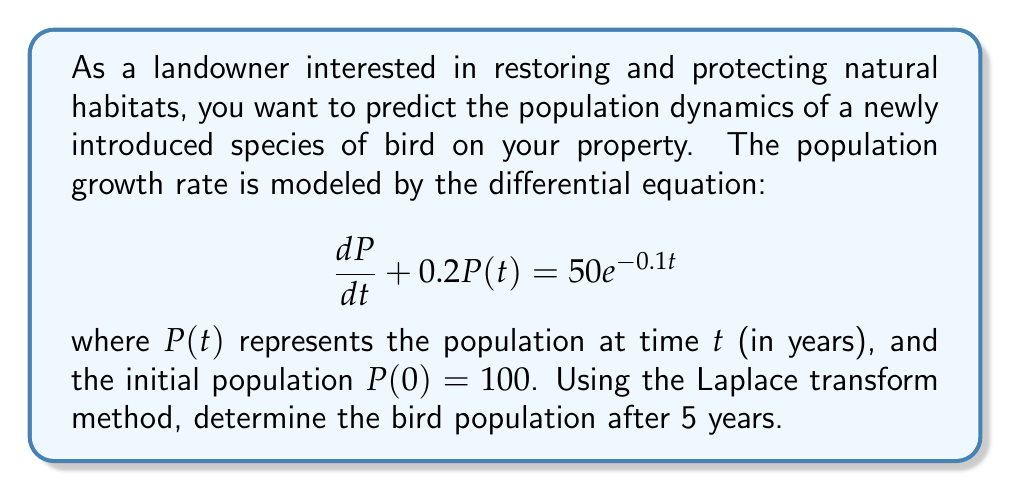Help me with this question. Let's solve this problem step-by-step using the Laplace transform method:

1) Take the Laplace transform of both sides of the equation:
   $$\mathcal{L}\{\frac{dP}{dt} + 0.2P(t)\} = \mathcal{L}\{50e^{-0.1t}\}$$

2) Using Laplace transform properties:
   $$sP(s) - P(0) + 0.2P(s) = \frac{50}{s+0.1}$$

3) Substitute the initial condition $P(0) = 100$:
   $$sP(s) - 100 + 0.2P(s) = \frac{50}{s+0.1}$$

4) Simplify:
   $$(s + 0.2)P(s) = 100 + \frac{50}{s+0.1}$$

5) Solve for $P(s)$:
   $$P(s) = \frac{100}{s + 0.2} + \frac{50}{(s + 0.2)(s + 0.1)}$$

6) Decompose the fraction:
   $$P(s) = \frac{100}{s + 0.2} + \frac{500}{s + 0.2} - \frac{500}{s + 0.1}$$

7) Take the inverse Laplace transform:
   $$P(t) = 100e^{-0.2t} + 500e^{-0.2t} - 500e^{-0.1t}$$

8) Simplify:
   $$P(t) = 600e^{-0.2t} - 500e^{-0.1t}$$

9) To find the population after 5 years, substitute $t = 5$:
   $$P(5) = 600e^{-0.2(5)} - 500e^{-0.1(5)}$$
   $$P(5) = 600e^{-1} - 500e^{-0.5}$$
   $$P(5) \approx 220.8 - 303.3 \approx -82.5$$

10) Since population cannot be negative, we interpret this as the population approaching zero.
Answer: 0 birds (population approaches extinction) 